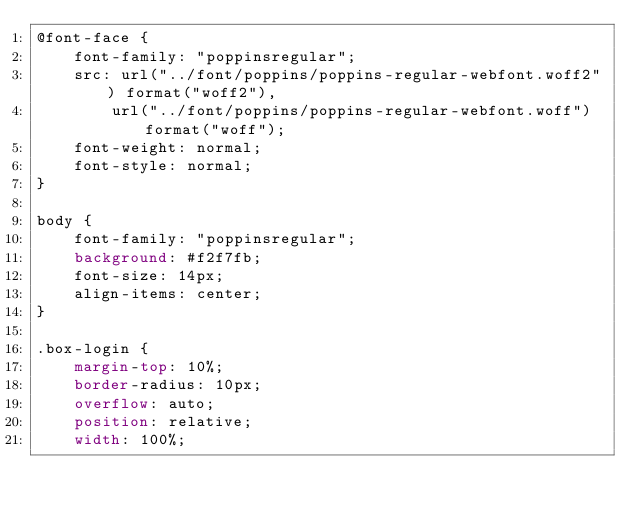<code> <loc_0><loc_0><loc_500><loc_500><_CSS_>@font-face {
    font-family: "poppinsregular";
    src: url("../font/poppins/poppins-regular-webfont.woff2") format("woff2"),
        url("../font/poppins/poppins-regular-webfont.woff") format("woff");
    font-weight: normal;
    font-style: normal;
}

body {
    font-family: "poppinsregular";
    background: #f2f7fb;
    font-size: 14px;
    align-items: center;
}

.box-login {
    margin-top: 10%;
    border-radius: 10px;
    overflow: auto;
    position: relative;
    width: 100%;</code> 